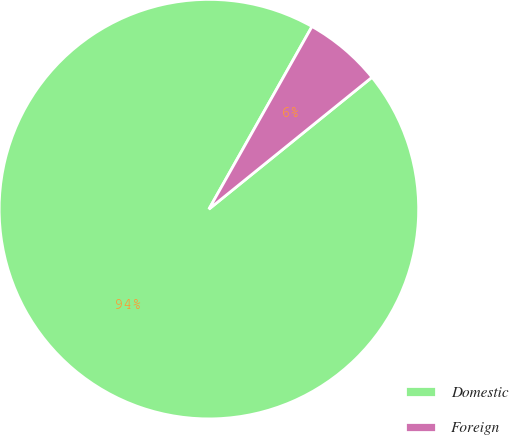Convert chart. <chart><loc_0><loc_0><loc_500><loc_500><pie_chart><fcel>Domestic<fcel>Foreign<nl><fcel>94.0%<fcel>6.0%<nl></chart> 